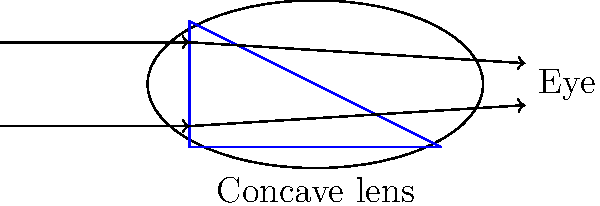A patient with myopia (nearsightedness) requires corrective lenses. The diagram shows a concave lens used to correct this condition. How does this lens help improve vision for individuals with myopia, and what implications does this have for healthcare policies supporting visual accessibility? 1. Myopia is a condition where light focuses in front of the retina, causing distant objects to appear blurry.

2. The concave lens in the diagram helps correct myopia by:
   a. Diverging incoming light rays
   b. Effectively moving the focal point backward

3. This correction allows light to focus directly on the retina, resulting in clearer vision for distant objects.

4. The process works as follows:
   a. Light rays enter the lens parallel to each other
   b. The concave shape causes the rays to diverge
   c. Diverged rays enter the eye at an angle that allows proper focusing on the retina

5. Healthcare policy implications:
   a. Ensuring access to proper vision screening for early detection of myopia
   b. Providing affordable corrective lenses to those in need
   c. Supporting research and development of advanced lens technologies
   d. Promoting awareness about the importance of regular eye exams
   e. Implementing policies to make public spaces more accessible for those with visual impairments

6. The effectiveness of concave lenses in correcting myopia demonstrates the importance of personalized healthcare solutions for individuals with disabilities.

7. Policy considerations should include coverage for regular eye exams, corrective lenses, and potential surgical interventions to ensure equal healthcare rights for individuals with visual impairments.
Answer: Concave lenses diverge light rays, correcting myopia by moving the focal point onto the retina. This highlights the need for policies ensuring access to personalized vision care and assistive technologies for individuals with visual impairments. 